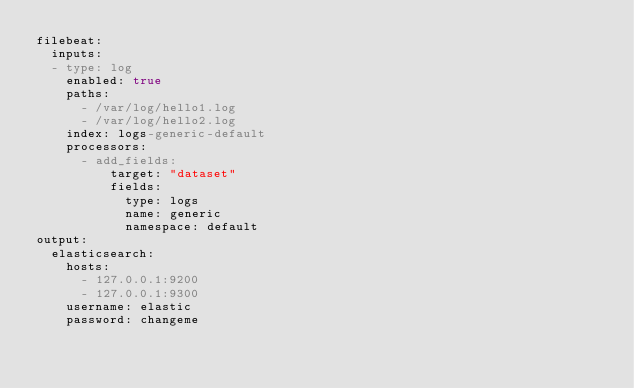Convert code to text. <code><loc_0><loc_0><loc_500><loc_500><_YAML_>filebeat:
  inputs:
  - type: log
    enabled: true
    paths:
      - /var/log/hello1.log
      - /var/log/hello2.log
    index: logs-generic-default
    processors:
      - add_fields:
          target: "dataset"
          fields:
            type: logs
            name: generic
            namespace: default
output:
  elasticsearch:
    hosts:
      - 127.0.0.1:9200
      - 127.0.0.1:9300
    username: elastic
    password: changeme
</code> 